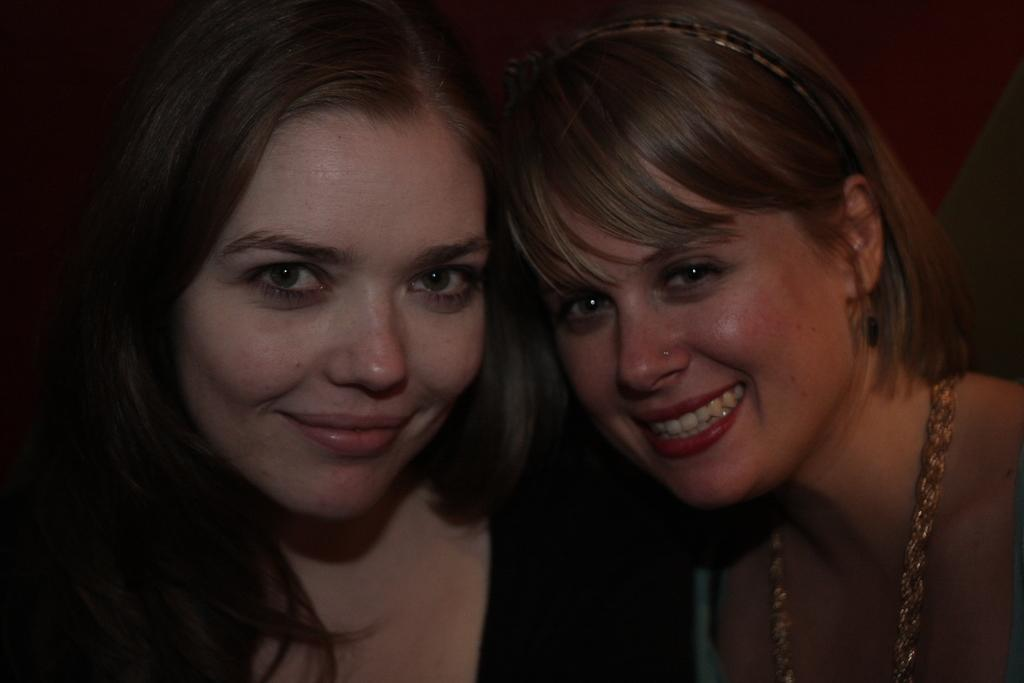How many women are present in the image? There are two women in the image. What expression do the women have in the image? The women are smiling in the image. What type of oatmeal is the woman on the left eating in the image? There is no oatmeal present in the image, and therefore no such activity can be observed. How tall are the giants in the image? There are no giants present in the image. What type of writing instrument is the woman on the right holding in the image? There is no writing instrument present in the image. 